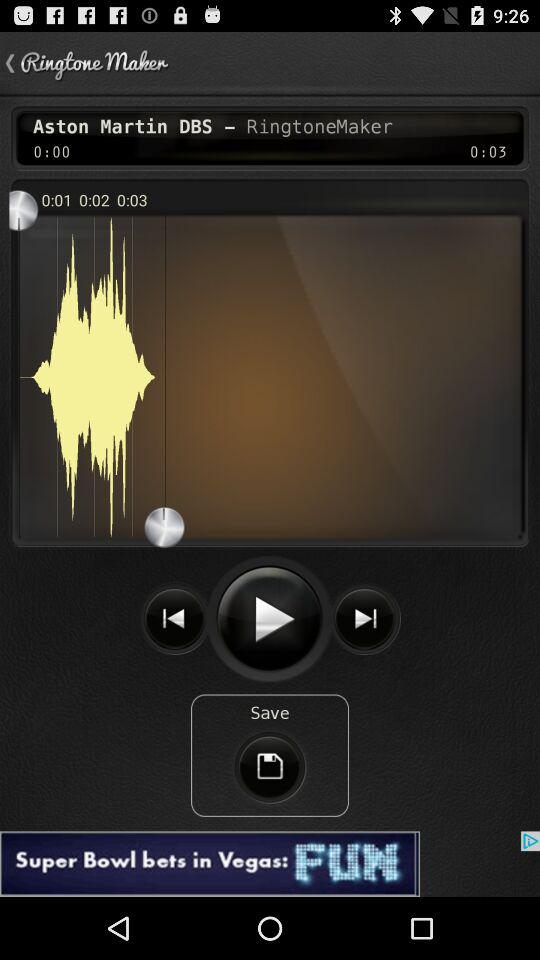What is the name of the application? The name of the application is "Ringtone Maker". 